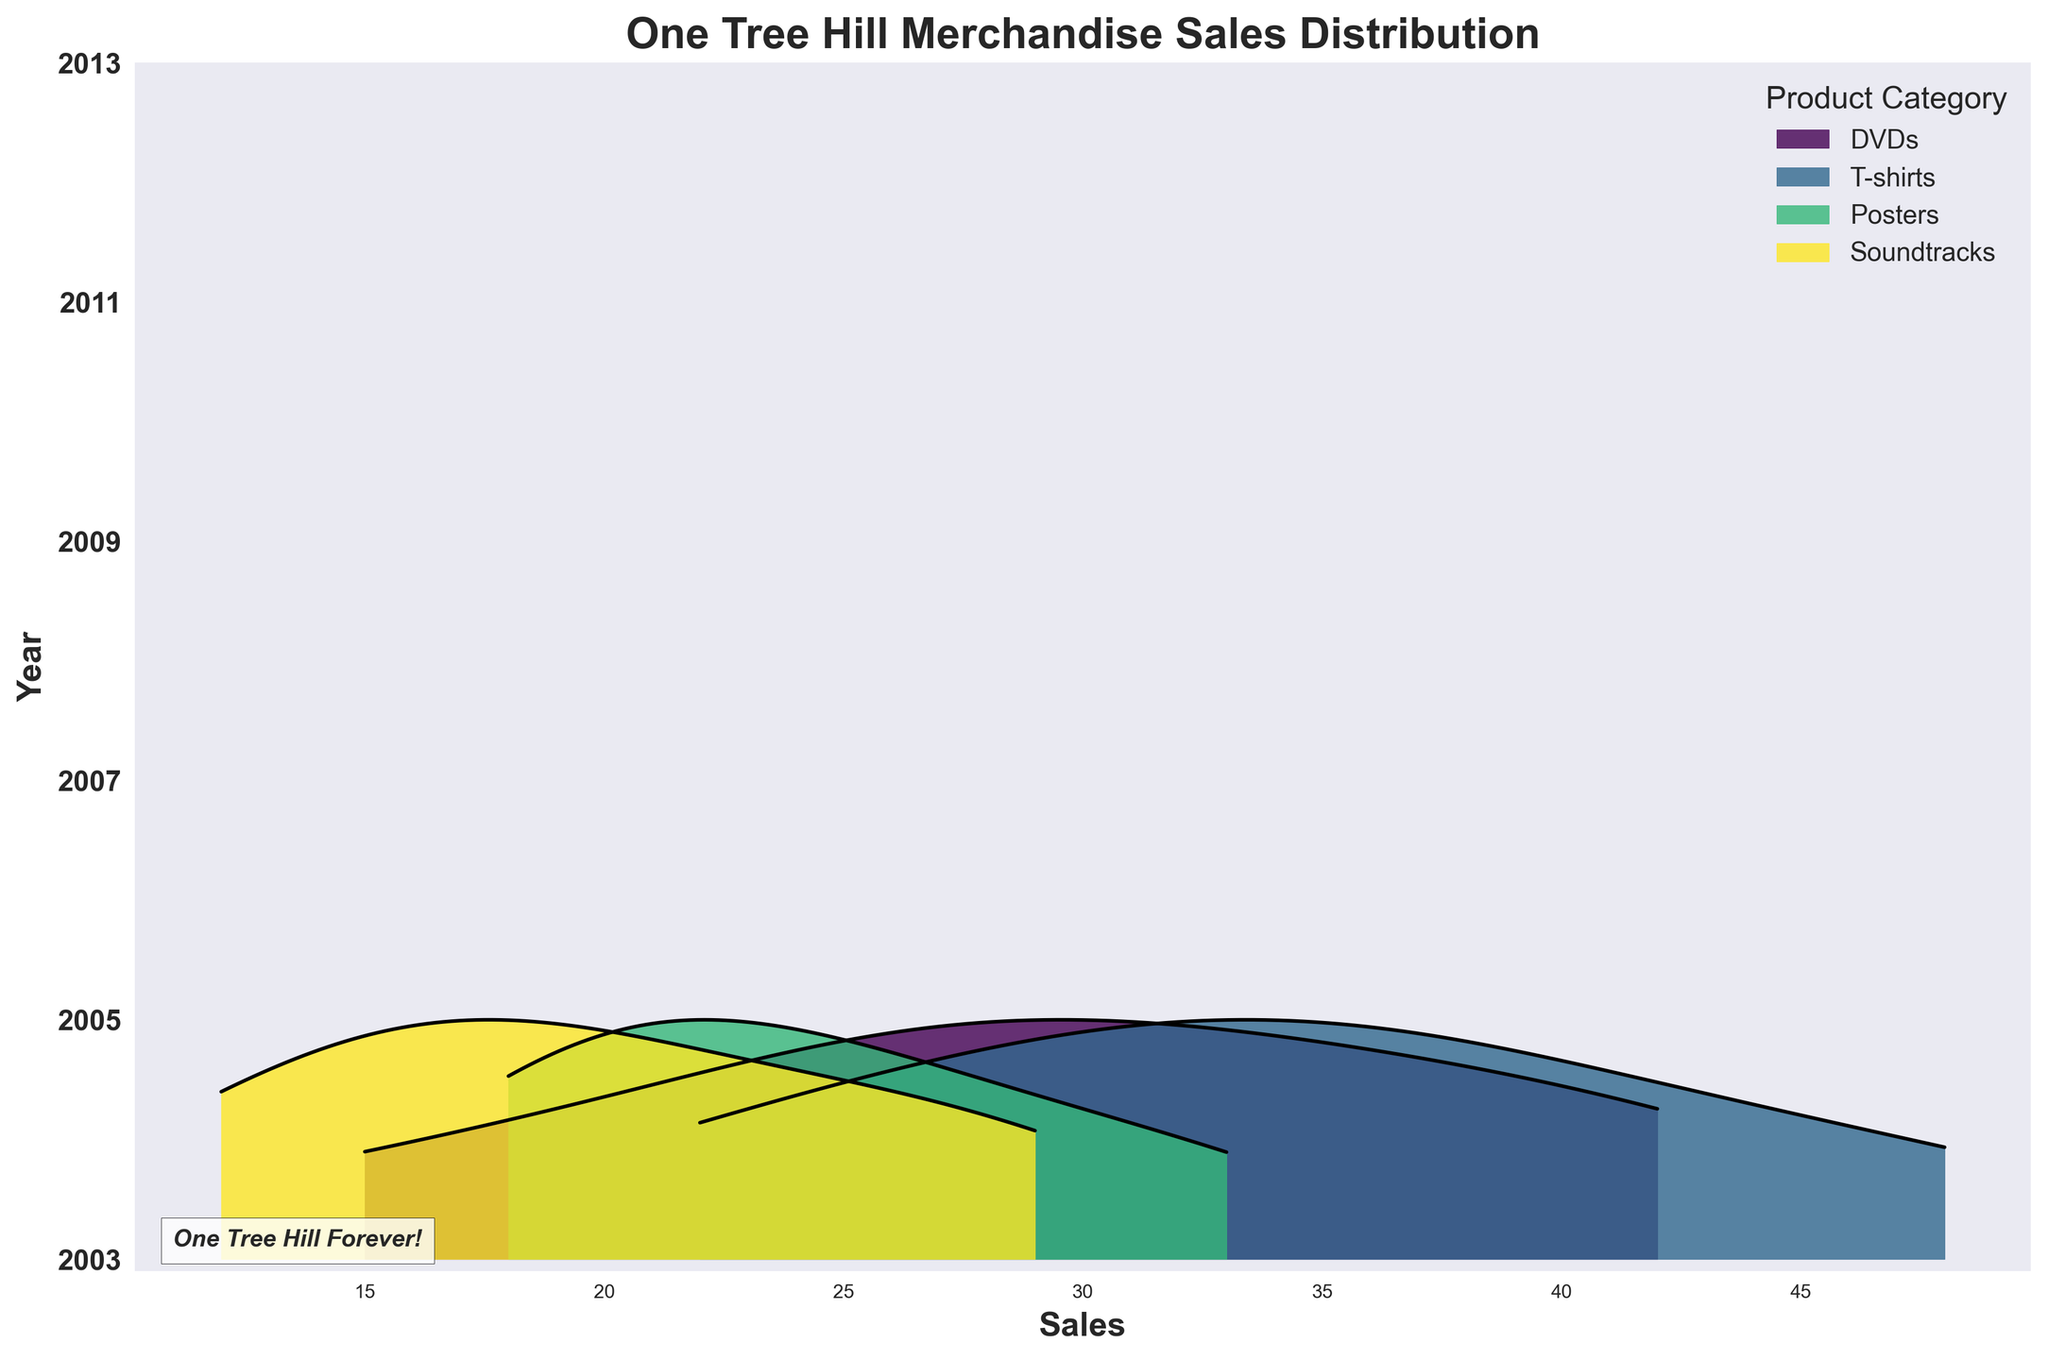what is the title of the plot? The title of the plot appears at the top and provides a summary of what the plot represents. In this case, it is written above the graph elements.
Answer: One Tree Hill Merchandise Sales Distribution Which product category has the highest sales in 2007? To determine which product category has the highest sales, we need to find the peak or the tallest ridgeline for the year 2007. Look for the category with the highest distribution curve in 2007.
Answer: T-shirts What were the sales for Posters in 2009? Follow the ridgeline corresponding to the 'Posters' category and trace it to the value on the x-axis for the year 2009. The height of the distribution will give a good indication of the sales value.
Answer: 28 How does the sales trend of DVDs from 2003 to 2013 look? Observe the ridgeline corresponding to the 'DVDs' category from 2003 to 2013. Look at the changes in height or position over these years to determine if it is increasing, decreasing, or stable.
Answer: Increased initially, then decreased What is the total sales of Soundtracks for all years combined? Sum up the sales (values) of 'Soundtracks' for each year given in the dataset: 12 (2003) + 20 (2005) + 29 (2007) + 25 (2009) + 18 (2011) + 15 (2013).
Answer: 119 Compare the sales of T-shirts and Posters in 2011. Which is higher? Identify the distribution curves for 'T-shirts' and 'Posters' for the year 2011. Compare their peak heights to determine which product category had higher sales.
Answer: T-shirts What can you infer about the popularity of Soundtracks over the years? Observe the trend of the ridgeline corresponding to 'Soundtracks' from 2003 to 2013 to infer if the sales increased, decreased, or remained constant.
Answer: Increased initially, then decreased Which year shows the highest overall merchandise sales in any category? Look for the year with the tallest ridgeline curve in any product category. The highest peak overall indicates the year with the highest sales.
Answer: 2007 What is the relative difference in sales of DVDs and T-shirts in 2005? Find the peaks of 'DVDs' and 'T-shirts' in 2005, then calculate the difference between their sales values: 35 (T-shirts) - 28 (DVDs).
Answer: 7 Between 2003 and 2007, which product category saw the most significant increase in sales? Compare the heights of the ridgeline curves for each category between 2003 and 2007 and identify which category shows the largest increase in sales value.
Answer: DVDs 